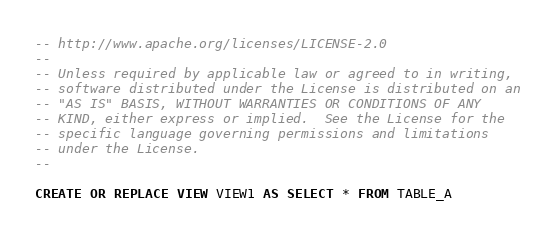<code> <loc_0><loc_0><loc_500><loc_500><_SQL_>-- http://www.apache.org/licenses/LICENSE-2.0
--
-- Unless required by applicable law or agreed to in writing,
-- software distributed under the License is distributed on an
-- "AS IS" BASIS, WITHOUT WARRANTIES OR CONDITIONS OF ANY
-- KIND, either express or implied.  See the License for the
-- specific language governing permissions and limitations
-- under the License.
--

CREATE OR REPLACE VIEW VIEW1 AS SELECT * FROM TABLE_A
</code> 